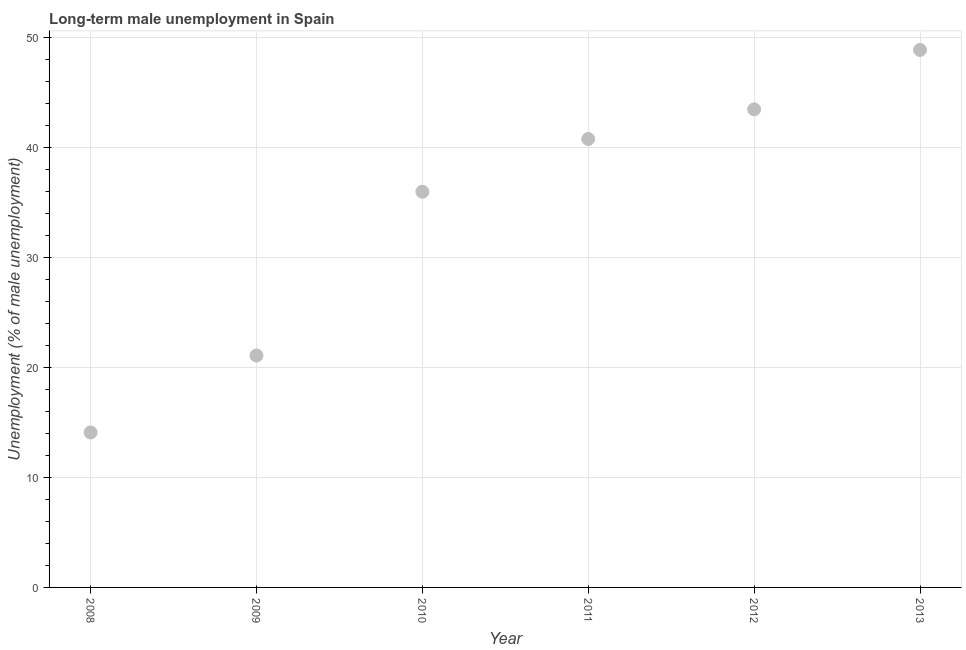What is the long-term male unemployment in 2012?
Provide a short and direct response. 43.5. Across all years, what is the maximum long-term male unemployment?
Your answer should be compact. 48.9. Across all years, what is the minimum long-term male unemployment?
Give a very brief answer. 14.1. What is the sum of the long-term male unemployment?
Ensure brevity in your answer.  204.4. What is the difference between the long-term male unemployment in 2008 and 2012?
Keep it short and to the point. -29.4. What is the average long-term male unemployment per year?
Offer a very short reply. 34.07. What is the median long-term male unemployment?
Your answer should be very brief. 38.4. Do a majority of the years between 2009 and 2011 (inclusive) have long-term male unemployment greater than 2 %?
Give a very brief answer. Yes. What is the ratio of the long-term male unemployment in 2009 to that in 2012?
Keep it short and to the point. 0.49. Is the long-term male unemployment in 2010 less than that in 2013?
Give a very brief answer. Yes. Is the difference between the long-term male unemployment in 2008 and 2010 greater than the difference between any two years?
Offer a terse response. No. What is the difference between the highest and the second highest long-term male unemployment?
Your response must be concise. 5.4. What is the difference between the highest and the lowest long-term male unemployment?
Offer a very short reply. 34.8. Does the long-term male unemployment monotonically increase over the years?
Your answer should be very brief. Yes. Are the values on the major ticks of Y-axis written in scientific E-notation?
Your answer should be compact. No. Does the graph contain any zero values?
Keep it short and to the point. No. Does the graph contain grids?
Your answer should be very brief. Yes. What is the title of the graph?
Your answer should be compact. Long-term male unemployment in Spain. What is the label or title of the Y-axis?
Offer a terse response. Unemployment (% of male unemployment). What is the Unemployment (% of male unemployment) in 2008?
Ensure brevity in your answer.  14.1. What is the Unemployment (% of male unemployment) in 2009?
Your response must be concise. 21.1. What is the Unemployment (% of male unemployment) in 2011?
Ensure brevity in your answer.  40.8. What is the Unemployment (% of male unemployment) in 2012?
Keep it short and to the point. 43.5. What is the Unemployment (% of male unemployment) in 2013?
Make the answer very short. 48.9. What is the difference between the Unemployment (% of male unemployment) in 2008 and 2010?
Offer a very short reply. -21.9. What is the difference between the Unemployment (% of male unemployment) in 2008 and 2011?
Offer a terse response. -26.7. What is the difference between the Unemployment (% of male unemployment) in 2008 and 2012?
Keep it short and to the point. -29.4. What is the difference between the Unemployment (% of male unemployment) in 2008 and 2013?
Provide a succinct answer. -34.8. What is the difference between the Unemployment (% of male unemployment) in 2009 and 2010?
Your answer should be very brief. -14.9. What is the difference between the Unemployment (% of male unemployment) in 2009 and 2011?
Your answer should be very brief. -19.7. What is the difference between the Unemployment (% of male unemployment) in 2009 and 2012?
Your answer should be compact. -22.4. What is the difference between the Unemployment (% of male unemployment) in 2009 and 2013?
Make the answer very short. -27.8. What is the difference between the Unemployment (% of male unemployment) in 2010 and 2013?
Your answer should be compact. -12.9. What is the difference between the Unemployment (% of male unemployment) in 2011 and 2012?
Your answer should be very brief. -2.7. What is the difference between the Unemployment (% of male unemployment) in 2011 and 2013?
Your answer should be very brief. -8.1. What is the difference between the Unemployment (% of male unemployment) in 2012 and 2013?
Offer a terse response. -5.4. What is the ratio of the Unemployment (% of male unemployment) in 2008 to that in 2009?
Offer a very short reply. 0.67. What is the ratio of the Unemployment (% of male unemployment) in 2008 to that in 2010?
Offer a very short reply. 0.39. What is the ratio of the Unemployment (% of male unemployment) in 2008 to that in 2011?
Provide a short and direct response. 0.35. What is the ratio of the Unemployment (% of male unemployment) in 2008 to that in 2012?
Give a very brief answer. 0.32. What is the ratio of the Unemployment (% of male unemployment) in 2008 to that in 2013?
Provide a short and direct response. 0.29. What is the ratio of the Unemployment (% of male unemployment) in 2009 to that in 2010?
Your response must be concise. 0.59. What is the ratio of the Unemployment (% of male unemployment) in 2009 to that in 2011?
Ensure brevity in your answer.  0.52. What is the ratio of the Unemployment (% of male unemployment) in 2009 to that in 2012?
Ensure brevity in your answer.  0.48. What is the ratio of the Unemployment (% of male unemployment) in 2009 to that in 2013?
Offer a terse response. 0.43. What is the ratio of the Unemployment (% of male unemployment) in 2010 to that in 2011?
Your answer should be very brief. 0.88. What is the ratio of the Unemployment (% of male unemployment) in 2010 to that in 2012?
Your response must be concise. 0.83. What is the ratio of the Unemployment (% of male unemployment) in 2010 to that in 2013?
Offer a terse response. 0.74. What is the ratio of the Unemployment (% of male unemployment) in 2011 to that in 2012?
Your answer should be very brief. 0.94. What is the ratio of the Unemployment (% of male unemployment) in 2011 to that in 2013?
Keep it short and to the point. 0.83. What is the ratio of the Unemployment (% of male unemployment) in 2012 to that in 2013?
Your answer should be very brief. 0.89. 